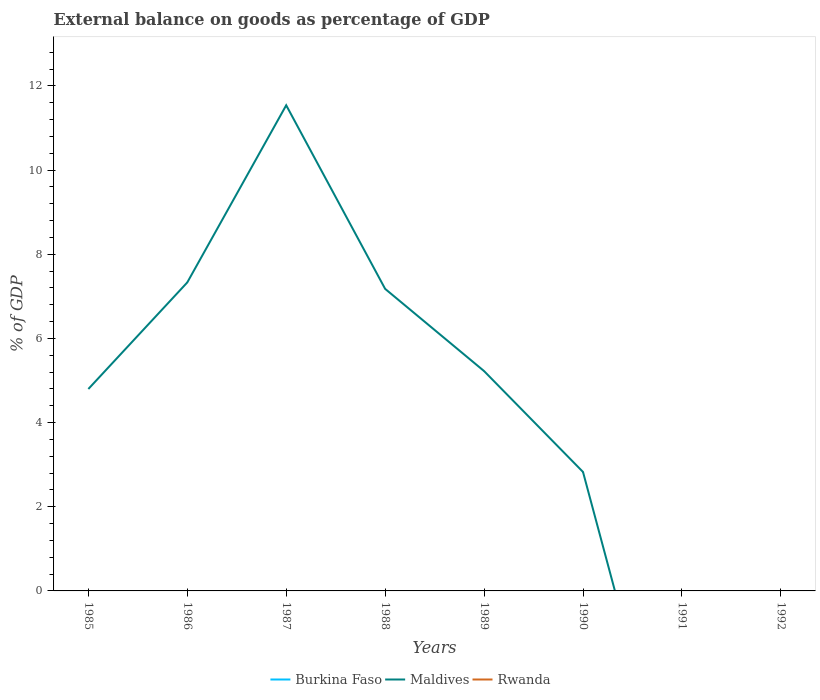Is the number of lines equal to the number of legend labels?
Offer a terse response. No. Across all years, what is the maximum external balance on goods as percentage of GDP in Burkina Faso?
Offer a terse response. 0. What is the difference between the highest and the second highest external balance on goods as percentage of GDP in Maldives?
Provide a short and direct response. 11.54. What is the difference between the highest and the lowest external balance on goods as percentage of GDP in Rwanda?
Your response must be concise. 0. How many years are there in the graph?
Offer a terse response. 8. What is the difference between two consecutive major ticks on the Y-axis?
Offer a very short reply. 2. Where does the legend appear in the graph?
Your answer should be compact. Bottom center. How are the legend labels stacked?
Keep it short and to the point. Horizontal. What is the title of the graph?
Provide a short and direct response. External balance on goods as percentage of GDP. What is the label or title of the Y-axis?
Offer a very short reply. % of GDP. What is the % of GDP in Maldives in 1985?
Provide a succinct answer. 4.8. What is the % of GDP in Rwanda in 1985?
Your answer should be compact. 0. What is the % of GDP of Maldives in 1986?
Offer a terse response. 7.33. What is the % of GDP in Rwanda in 1986?
Offer a terse response. 0. What is the % of GDP in Maldives in 1987?
Your answer should be very brief. 11.54. What is the % of GDP of Maldives in 1988?
Your answer should be compact. 7.18. What is the % of GDP in Burkina Faso in 1989?
Give a very brief answer. 0. What is the % of GDP of Maldives in 1989?
Give a very brief answer. 5.22. What is the % of GDP in Maldives in 1990?
Your answer should be very brief. 2.83. What is the % of GDP of Rwanda in 1991?
Keep it short and to the point. 0. What is the % of GDP in Rwanda in 1992?
Your answer should be very brief. 0. Across all years, what is the maximum % of GDP in Maldives?
Give a very brief answer. 11.54. What is the total % of GDP of Maldives in the graph?
Offer a terse response. 38.89. What is the difference between the % of GDP of Maldives in 1985 and that in 1986?
Ensure brevity in your answer.  -2.53. What is the difference between the % of GDP of Maldives in 1985 and that in 1987?
Make the answer very short. -6.74. What is the difference between the % of GDP of Maldives in 1985 and that in 1988?
Your answer should be compact. -2.38. What is the difference between the % of GDP of Maldives in 1985 and that in 1989?
Keep it short and to the point. -0.43. What is the difference between the % of GDP of Maldives in 1985 and that in 1990?
Make the answer very short. 1.97. What is the difference between the % of GDP in Maldives in 1986 and that in 1987?
Offer a terse response. -4.21. What is the difference between the % of GDP of Maldives in 1986 and that in 1988?
Your response must be concise. 0.15. What is the difference between the % of GDP in Maldives in 1986 and that in 1989?
Make the answer very short. 2.11. What is the difference between the % of GDP of Maldives in 1986 and that in 1990?
Provide a short and direct response. 4.5. What is the difference between the % of GDP of Maldives in 1987 and that in 1988?
Your answer should be compact. 4.36. What is the difference between the % of GDP in Maldives in 1987 and that in 1989?
Keep it short and to the point. 6.32. What is the difference between the % of GDP of Maldives in 1987 and that in 1990?
Your answer should be compact. 8.71. What is the difference between the % of GDP of Maldives in 1988 and that in 1989?
Give a very brief answer. 1.95. What is the difference between the % of GDP of Maldives in 1988 and that in 1990?
Ensure brevity in your answer.  4.35. What is the difference between the % of GDP of Maldives in 1989 and that in 1990?
Your answer should be compact. 2.4. What is the average % of GDP in Burkina Faso per year?
Ensure brevity in your answer.  0. What is the average % of GDP of Maldives per year?
Give a very brief answer. 4.86. What is the average % of GDP of Rwanda per year?
Provide a short and direct response. 0. What is the ratio of the % of GDP of Maldives in 1985 to that in 1986?
Your response must be concise. 0.65. What is the ratio of the % of GDP of Maldives in 1985 to that in 1987?
Provide a succinct answer. 0.42. What is the ratio of the % of GDP of Maldives in 1985 to that in 1988?
Provide a short and direct response. 0.67. What is the ratio of the % of GDP in Maldives in 1985 to that in 1989?
Keep it short and to the point. 0.92. What is the ratio of the % of GDP of Maldives in 1985 to that in 1990?
Provide a short and direct response. 1.7. What is the ratio of the % of GDP in Maldives in 1986 to that in 1987?
Provide a short and direct response. 0.64. What is the ratio of the % of GDP of Maldives in 1986 to that in 1988?
Your answer should be compact. 1.02. What is the ratio of the % of GDP of Maldives in 1986 to that in 1989?
Offer a very short reply. 1.4. What is the ratio of the % of GDP of Maldives in 1986 to that in 1990?
Your answer should be compact. 2.59. What is the ratio of the % of GDP in Maldives in 1987 to that in 1988?
Provide a short and direct response. 1.61. What is the ratio of the % of GDP in Maldives in 1987 to that in 1989?
Your answer should be very brief. 2.21. What is the ratio of the % of GDP of Maldives in 1987 to that in 1990?
Offer a terse response. 4.08. What is the ratio of the % of GDP in Maldives in 1988 to that in 1989?
Your response must be concise. 1.37. What is the ratio of the % of GDP in Maldives in 1988 to that in 1990?
Ensure brevity in your answer.  2.54. What is the ratio of the % of GDP of Maldives in 1989 to that in 1990?
Your response must be concise. 1.85. What is the difference between the highest and the second highest % of GDP of Maldives?
Ensure brevity in your answer.  4.21. What is the difference between the highest and the lowest % of GDP of Maldives?
Provide a short and direct response. 11.54. 